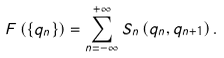<formula> <loc_0><loc_0><loc_500><loc_500>F \left ( \left \{ q _ { n } \right \} \right ) = \sum ^ { + \infty } _ { n = - \infty } S _ { n } \left ( q _ { n } , q _ { n + 1 } \right ) .</formula> 